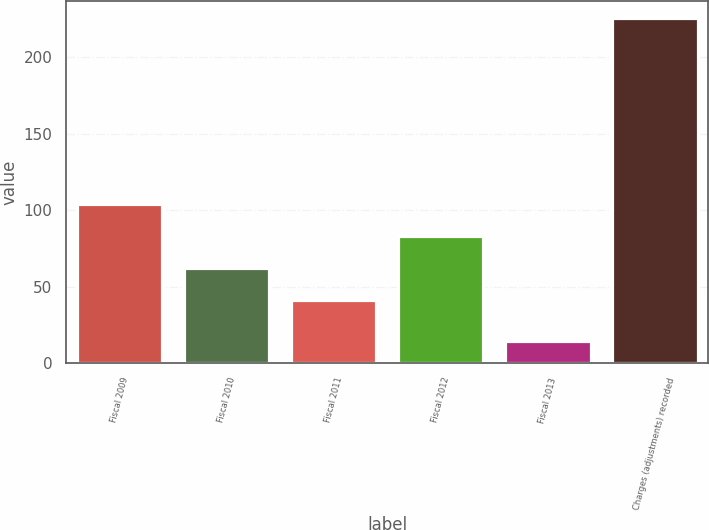<chart> <loc_0><loc_0><loc_500><loc_500><bar_chart><fcel>Fiscal 2009<fcel>Fiscal 2010<fcel>Fiscal 2011<fcel>Fiscal 2012<fcel>Fiscal 2013<fcel>Charges (adjustments) recorded<nl><fcel>104.37<fcel>62.19<fcel>41.1<fcel>83.28<fcel>14.6<fcel>225.5<nl></chart> 